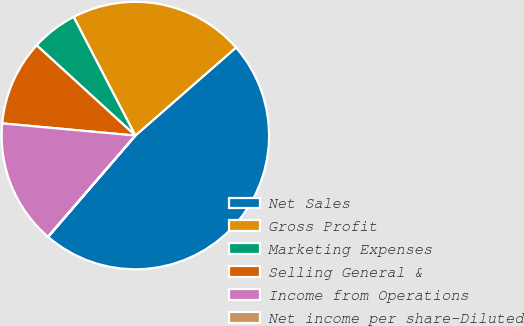<chart> <loc_0><loc_0><loc_500><loc_500><pie_chart><fcel>Net Sales<fcel>Gross Profit<fcel>Marketing Expenses<fcel>Selling General &<fcel>Income from Operations<fcel>Net income per share-Diluted<nl><fcel>47.75%<fcel>21.2%<fcel>5.57%<fcel>10.34%<fcel>15.11%<fcel>0.03%<nl></chart> 